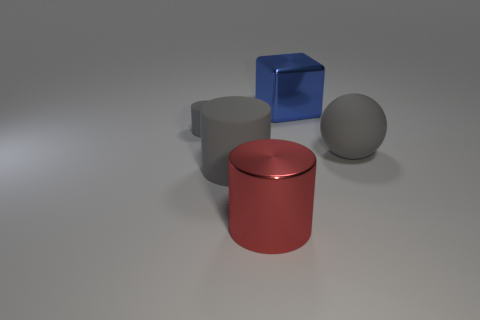Can you indicate which object might be the heaviest based on their size and appearance? While we cannot directly assess weight through appearance alone, the red cylinder looks substantial in size and could be perceived as the heaviest if made from a dense material like metal, while the sphere and the cube might be lighter, especially if the materials are rubber or hollow. 